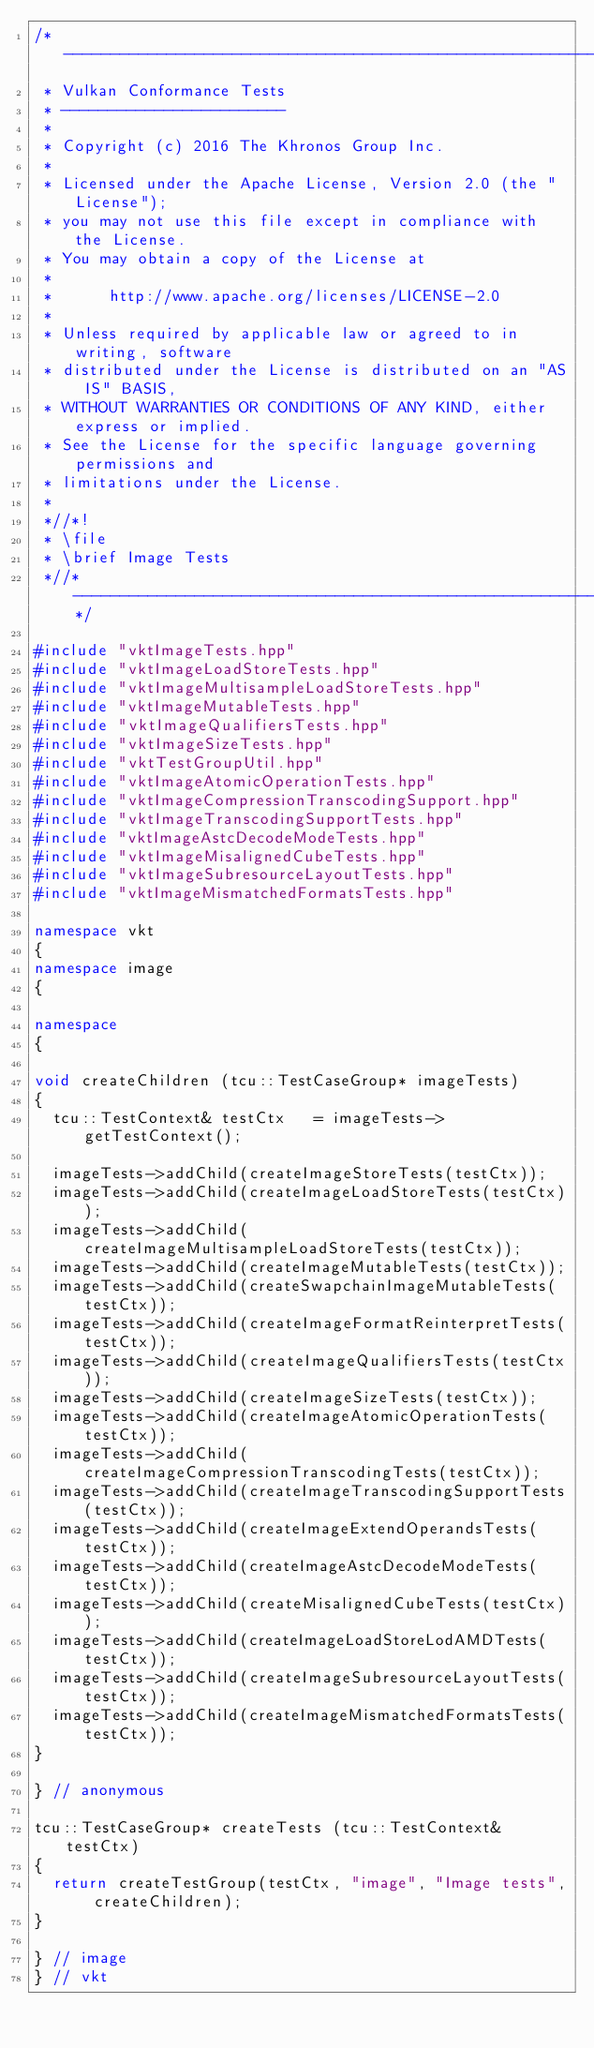<code> <loc_0><loc_0><loc_500><loc_500><_C++_>/*------------------------------------------------------------------------
 * Vulkan Conformance Tests
 * ------------------------
 *
 * Copyright (c) 2016 The Khronos Group Inc.
 *
 * Licensed under the Apache License, Version 2.0 (the "License");
 * you may not use this file except in compliance with the License.
 * You may obtain a copy of the License at
 *
 *      http://www.apache.org/licenses/LICENSE-2.0
 *
 * Unless required by applicable law or agreed to in writing, software
 * distributed under the License is distributed on an "AS IS" BASIS,
 * WITHOUT WARRANTIES OR CONDITIONS OF ANY KIND, either express or implied.
 * See the License for the specific language governing permissions and
 * limitations under the License.
 *
 *//*!
 * \file
 * \brief Image Tests
 *//*--------------------------------------------------------------------*/

#include "vktImageTests.hpp"
#include "vktImageLoadStoreTests.hpp"
#include "vktImageMultisampleLoadStoreTests.hpp"
#include "vktImageMutableTests.hpp"
#include "vktImageQualifiersTests.hpp"
#include "vktImageSizeTests.hpp"
#include "vktTestGroupUtil.hpp"
#include "vktImageAtomicOperationTests.hpp"
#include "vktImageCompressionTranscodingSupport.hpp"
#include "vktImageTranscodingSupportTests.hpp"
#include "vktImageAstcDecodeModeTests.hpp"
#include "vktImageMisalignedCubeTests.hpp"
#include "vktImageSubresourceLayoutTests.hpp"
#include "vktImageMismatchedFormatsTests.hpp"

namespace vkt
{
namespace image
{

namespace
{

void createChildren (tcu::TestCaseGroup* imageTests)
{
	tcu::TestContext&	testCtx		= imageTests->getTestContext();

	imageTests->addChild(createImageStoreTests(testCtx));
	imageTests->addChild(createImageLoadStoreTests(testCtx));
	imageTests->addChild(createImageMultisampleLoadStoreTests(testCtx));
	imageTests->addChild(createImageMutableTests(testCtx));
	imageTests->addChild(createSwapchainImageMutableTests(testCtx));
	imageTests->addChild(createImageFormatReinterpretTests(testCtx));
	imageTests->addChild(createImageQualifiersTests(testCtx));
	imageTests->addChild(createImageSizeTests(testCtx));
	imageTests->addChild(createImageAtomicOperationTests(testCtx));
	imageTests->addChild(createImageCompressionTranscodingTests(testCtx));
	imageTests->addChild(createImageTranscodingSupportTests(testCtx));
	imageTests->addChild(createImageExtendOperandsTests(testCtx));
	imageTests->addChild(createImageAstcDecodeModeTests(testCtx));
	imageTests->addChild(createMisalignedCubeTests(testCtx));
	imageTests->addChild(createImageLoadStoreLodAMDTests(testCtx));
	imageTests->addChild(createImageSubresourceLayoutTests(testCtx));
	imageTests->addChild(createImageMismatchedFormatsTests(testCtx));
}

} // anonymous

tcu::TestCaseGroup* createTests (tcu::TestContext& testCtx)
{
	return createTestGroup(testCtx, "image", "Image tests", createChildren);
}

} // image
} // vkt
</code> 